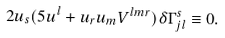<formula> <loc_0><loc_0><loc_500><loc_500>2 u _ { s } ( 5 u ^ { l } + u _ { r } u _ { m } V ^ { l m r } ) \delta \Gamma _ { j l } ^ { s } \equiv 0 { . }</formula> 